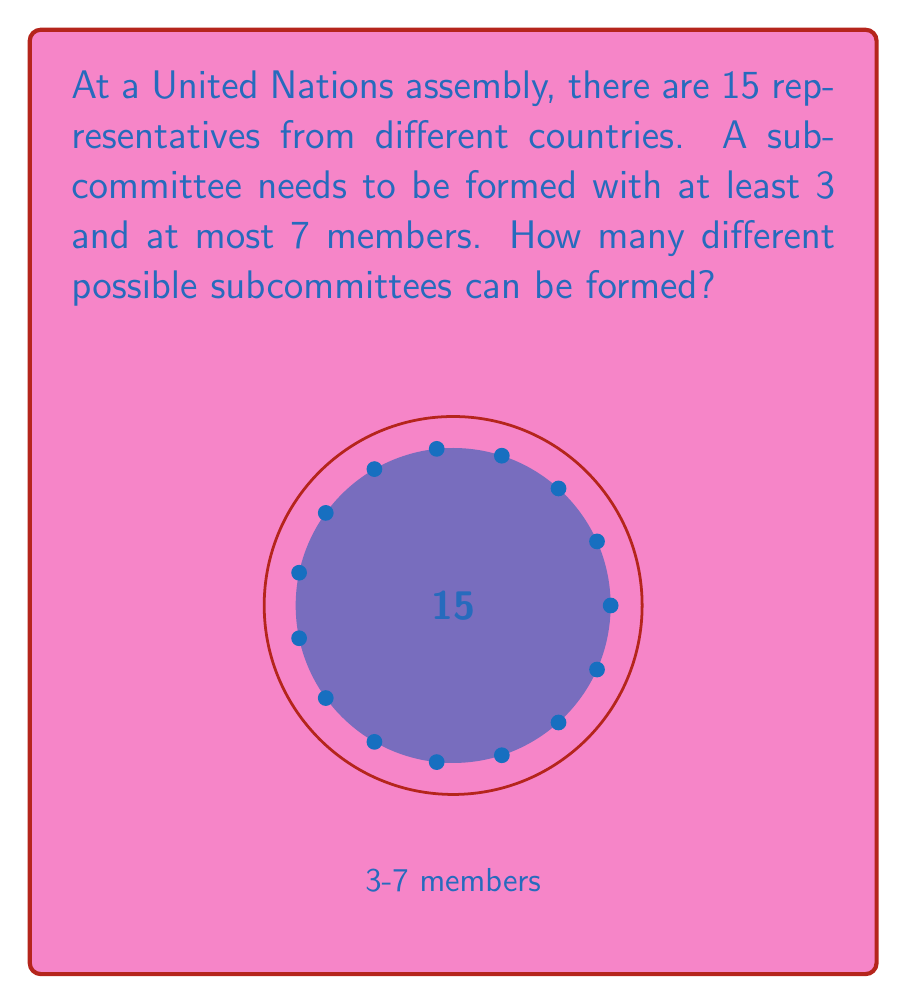Solve this math problem. To solve this problem, we need to use the concept of combinations from group theory. We'll calculate the number of ways to select subcommittees of each allowed size and then sum these up.

1) For a subcommittee of size k from n representatives, we use the combination formula:

   $${n \choose k} = \frac{n!}{k!(n-k)!}$$

2) We need to calculate this for k = 3, 4, 5, 6, and 7, with n = 15:

   For 3 members: $${15 \choose 3} = \frac{15!}{3!(15-3)!} = 455$$
   For 4 members: $${15 \choose 4} = \frac{15!}{4!(15-4)!} = 1365$$
   For 5 members: $${15 \choose 5} = \frac{15!}{5!(15-5)!} = 3003$$
   For 6 members: $${15 \choose 6} = \frac{15!}{6!(15-6)!} = 5005$$
   For 7 members: $${15 \choose 7} = \frac{15!}{7!(15-7)!} = 6435$$

3) The total number of possible subcommittees is the sum of all these combinations:

   $$455 + 1365 + 3003 + 5005 + 6435 = 16263$$

Therefore, there are 16,263 different possible subcommittees that can be formed.
Answer: 16,263 